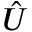<formula> <loc_0><loc_0><loc_500><loc_500>\hat { U }</formula> 